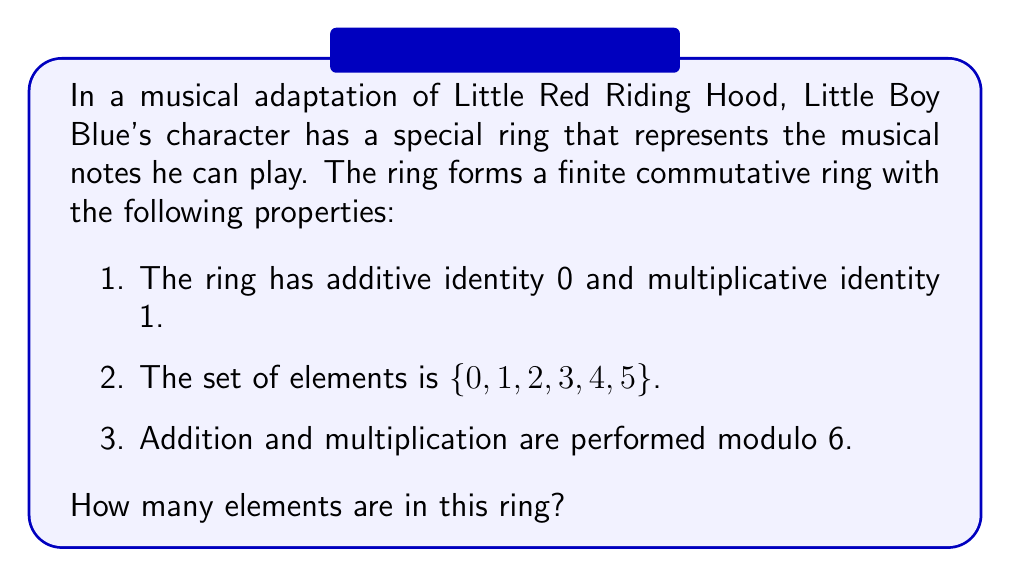Show me your answer to this math problem. To determine the number of elements in this finite commutative ring, we simply need to count the distinct elements given in the set. Let's break it down:

1. The set of elements is explicitly given as $\{0, 1, 2, 3, 4, 5\}$.

2. We can verify that this set forms a ring under addition and multiplication modulo 6:

   a. Closure: Any sum or product of two elements, when taken modulo 6, will result in an element within the set.
   
   b. Associativity: Both addition and multiplication modulo 6 are associative.
   
   c. Commutativity: Both operations are commutative in modulo 6 arithmetic.
   
   d. Distributivity: Multiplication distributes over addition in modulo 6 arithmetic.
   
   e. Additive identity: 0 is the additive identity.
   
   f. Multiplicative identity: 1 is the multiplicative identity.
   
   g. Additive inverses: Each element has an additive inverse within the set.

3. To count the elements, we simply need to count the number of distinct values in the set:

   $\{0, 1, 2, 3, 4, 5\}$

4. Counting these elements, we find that there are 6 distinct elements in the ring.

Therefore, the number of elements in this finite commutative ring is 6.
Answer: 6 